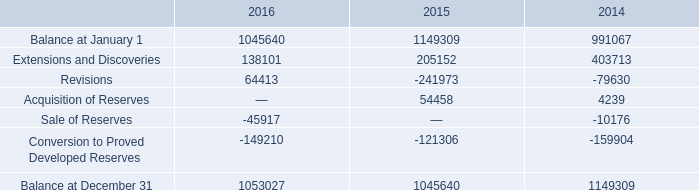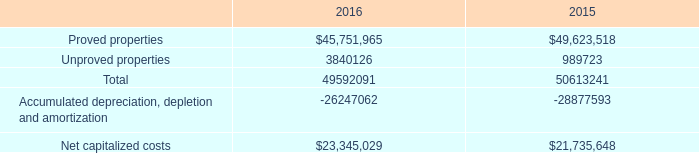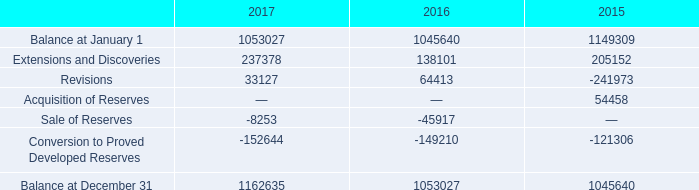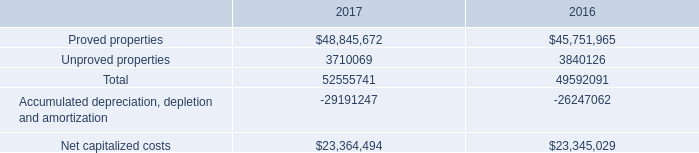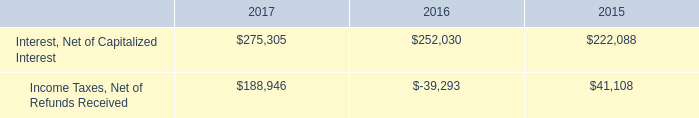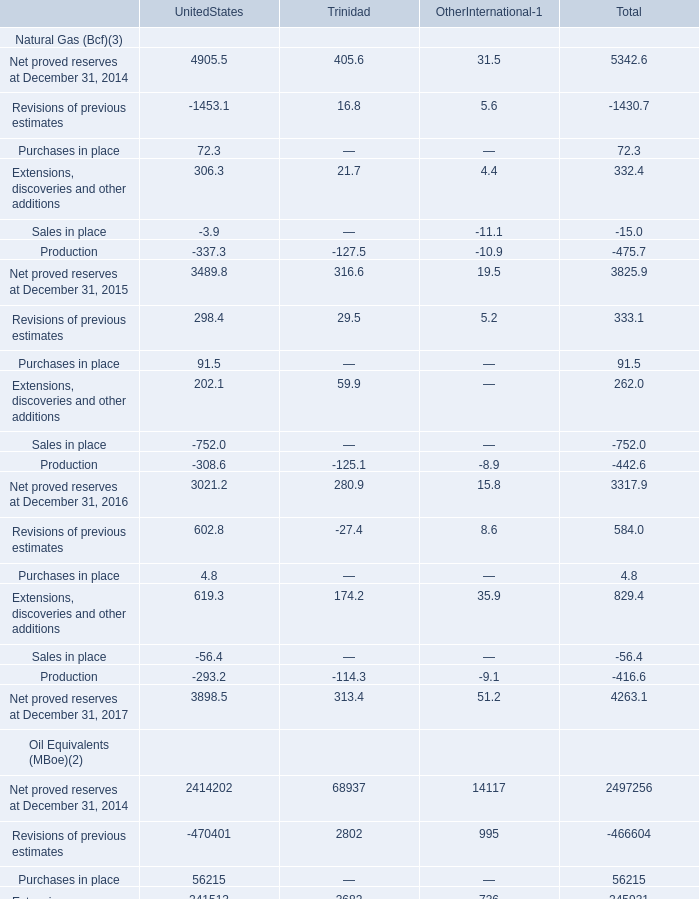In which year is purchase in place of oil equivalent(MBoe) in total greater than 50000? 
Answer: 2015. 